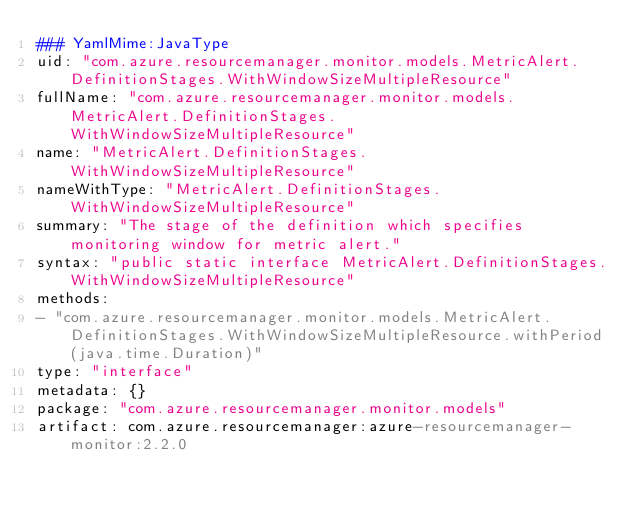<code> <loc_0><loc_0><loc_500><loc_500><_YAML_>### YamlMime:JavaType
uid: "com.azure.resourcemanager.monitor.models.MetricAlert.DefinitionStages.WithWindowSizeMultipleResource"
fullName: "com.azure.resourcemanager.monitor.models.MetricAlert.DefinitionStages.WithWindowSizeMultipleResource"
name: "MetricAlert.DefinitionStages.WithWindowSizeMultipleResource"
nameWithType: "MetricAlert.DefinitionStages.WithWindowSizeMultipleResource"
summary: "The stage of the definition which specifies monitoring window for metric alert."
syntax: "public static interface MetricAlert.DefinitionStages.WithWindowSizeMultipleResource"
methods:
- "com.azure.resourcemanager.monitor.models.MetricAlert.DefinitionStages.WithWindowSizeMultipleResource.withPeriod(java.time.Duration)"
type: "interface"
metadata: {}
package: "com.azure.resourcemanager.monitor.models"
artifact: com.azure.resourcemanager:azure-resourcemanager-monitor:2.2.0
</code> 